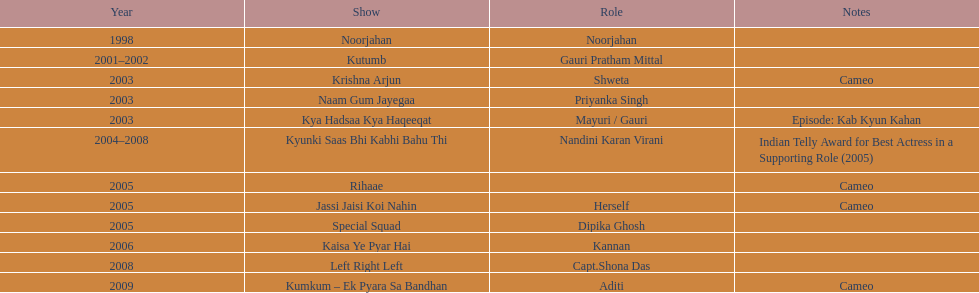What was the maximum number of years a show continued? 4. 